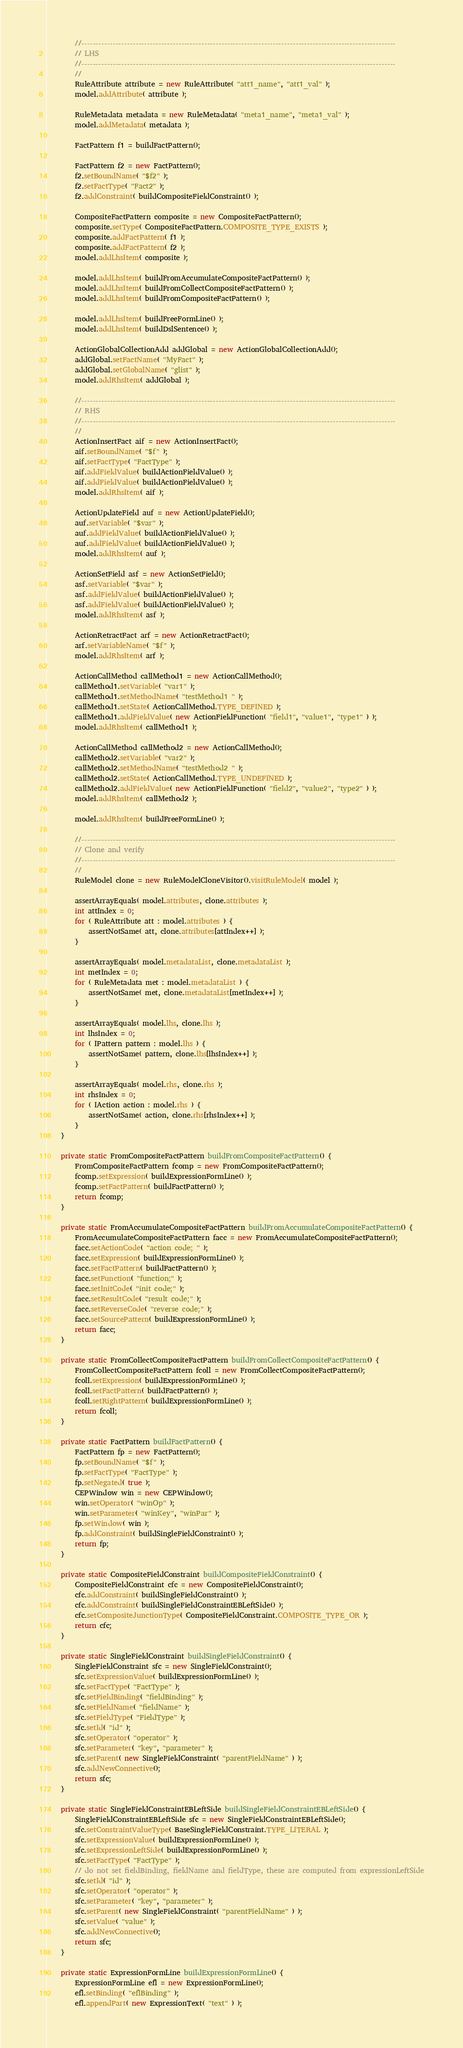<code> <loc_0><loc_0><loc_500><loc_500><_Java_>        //--------------------------------------------------------------------------------------------------------------
        // LHS
        //--------------------------------------------------------------------------------------------------------------
        //
        RuleAttribute attribute = new RuleAttribute( "att1_name", "att1_val" );
        model.addAttribute( attribute );

        RuleMetadata metadata = new RuleMetadata( "meta1_name", "meta1_val" );
        model.addMetadata( metadata );

        FactPattern f1 = buildFactPattern();

        FactPattern f2 = new FactPattern();
        f2.setBoundName( "$f2" );
        f2.setFactType( "Fact2" );
        f2.addConstraint( buildCompositeFieldConstraint() );

        CompositeFactPattern composite = new CompositeFactPattern();
        composite.setType( CompositeFactPattern.COMPOSITE_TYPE_EXISTS );
        composite.addFactPattern( f1 );
        composite.addFactPattern( f2 );
        model.addLhsItem( composite );

        model.addLhsItem( buildFromAccumulateCompositeFactPattern() );
        model.addLhsItem( buildFromCollectCompositeFactPattern() );
        model.addLhsItem( buildFromCompositeFactPattern() );

        model.addLhsItem( buildFreeFormLine() );
        model.addLhsItem( buildDslSentence() );

        ActionGlobalCollectionAdd addGlobal = new ActionGlobalCollectionAdd();
        addGlobal.setFactName( "MyFact" );
        addGlobal.setGlobalName( "glist" );
        model.addRhsItem( addGlobal );

        //--------------------------------------------------------------------------------------------------------------
        // RHS
        //--------------------------------------------------------------------------------------------------------------
        //
        ActionInsertFact aif = new ActionInsertFact();
        aif.setBoundName( "$f" );
        aif.setFactType( "FactType" );
        aif.addFieldValue( buildActionFieldValue() );
        aif.addFieldValue( buildActionFieldValue() );
        model.addRhsItem( aif );

        ActionUpdateField auf = new ActionUpdateField();
        auf.setVariable( "$var" );
        auf.addFieldValue( buildActionFieldValue() );
        auf.addFieldValue( buildActionFieldValue() );
        model.addRhsItem( auf );

        ActionSetField asf = new ActionSetField();
        asf.setVariable( "$var" );
        asf.addFieldValue( buildActionFieldValue() );
        asf.addFieldValue( buildActionFieldValue() );
        model.addRhsItem( asf );

        ActionRetractFact arf = new ActionRetractFact();
        arf.setVariableName( "$f" );
        model.addRhsItem( arf );

        ActionCallMethod callMethod1 = new ActionCallMethod();
        callMethod1.setVariable( "var1" );
        callMethod1.setMethodName( "testMethod1 " );
        callMethod1.setState( ActionCallMethod.TYPE_DEFINED );
        callMethod1.addFieldValue( new ActionFieldFunction( "field1", "value1", "type1" ) );
        model.addRhsItem( callMethod1 );

        ActionCallMethod callMethod2 = new ActionCallMethod();
        callMethod2.setVariable( "var2" );
        callMethod2.setMethodName( "testMethod2 " );
        callMethod2.setState( ActionCallMethod.TYPE_UNDEFINED );
        callMethod2.addFieldValue( new ActionFieldFunction( "field2", "value2", "type2" ) );
        model.addRhsItem( callMethod2 );

        model.addRhsItem( buildFreeFormLine() );

        //--------------------------------------------------------------------------------------------------------------
        // Clone and verify
        //--------------------------------------------------------------------------------------------------------------
        //
        RuleModel clone = new RuleModelCloneVisitor().visitRuleModel( model );

        assertArrayEquals( model.attributes, clone.attributes );
        int attIndex = 0;
        for ( RuleAttribute att : model.attributes ) {
            assertNotSame( att, clone.attributes[attIndex++] );
        }

        assertArrayEquals( model.metadataList, clone.metadataList );
        int metIndex = 0;
        for ( RuleMetadata met : model.metadataList ) {
            assertNotSame( met, clone.metadataList[metIndex++] );
        }

        assertArrayEquals( model.lhs, clone.lhs );
        int lhsIndex = 0;
        for ( IPattern pattern : model.lhs ) {
            assertNotSame( pattern, clone.lhs[lhsIndex++] );
        }

        assertArrayEquals( model.rhs, clone.rhs );
        int rhsIndex = 0;
        for ( IAction action : model.rhs ) {
            assertNotSame( action, clone.rhs[rhsIndex++] );
        }
    }

    private static FromCompositeFactPattern buildFromCompositeFactPattern() {
        FromCompositeFactPattern fcomp = new FromCompositeFactPattern();
        fcomp.setExpression( buildExpressionFormLine() );
        fcomp.setFactPattern( buildFactPattern() );
        return fcomp;
    }

    private static FromAccumulateCompositeFactPattern buildFromAccumulateCompositeFactPattern() {
        FromAccumulateCompositeFactPattern facc = new FromAccumulateCompositeFactPattern();
        facc.setActionCode( "action code; " );
        facc.setExpression( buildExpressionFormLine() );
        facc.setFactPattern( buildFactPattern() );
        facc.setFunction( "function;" );
        facc.setInitCode( "init code;" );
        facc.setResultCode( "result code;" );
        facc.setReverseCode( "reverse code;" );
        facc.setSourcePattern( buildExpressionFormLine() );
        return facc;
    }

    private static FromCollectCompositeFactPattern buildFromCollectCompositeFactPattern() {
        FromCollectCompositeFactPattern fcoll = new FromCollectCompositeFactPattern();
        fcoll.setExpression( buildExpressionFormLine() );
        fcoll.setFactPattern( buildFactPattern() );
        fcoll.setRightPattern( buildExpressionFormLine() );
        return fcoll;
    }

    private static FactPattern buildFactPattern() {
        FactPattern fp = new FactPattern();
        fp.setBoundName( "$f" );
        fp.setFactType( "FactType" );
        fp.setNegated( true );
        CEPWindow win = new CEPWindow();
        win.setOperator( "winOp" );
        win.setParameter( "winKey", "winPar" );
        fp.setWindow( win );
        fp.addConstraint( buildSingleFieldConstraint() );
        return fp;
    }

    private static CompositeFieldConstraint buildCompositeFieldConstraint() {
        CompositeFieldConstraint cfc = new CompositeFieldConstraint();
        cfc.addConstraint( buildSingleFieldConstraint() );
        cfc.addConstraint( buildSingleFieldConstraintEBLeftSide() );
        cfc.setCompositeJunctionType( CompositeFieldConstraint.COMPOSITE_TYPE_OR );
        return cfc;
    }

    private static SingleFieldConstraint buildSingleFieldConstraint() {
        SingleFieldConstraint sfc = new SingleFieldConstraint();
        sfc.setExpressionValue( buildExpressionFormLine() );
        sfc.setFactType( "FactType" );
        sfc.setFieldBinding( "fieldBinding" );
        sfc.setFieldName( "fieldName" );
        sfc.setFieldType( "FieldType" );
        sfc.setId( "id" );
        sfc.setOperator( "operator" );
        sfc.setParameter( "key", "parameter" );
        sfc.setParent( new SingleFieldConstraint( "parentFieldName" ) );
        sfc.addNewConnective();
        return sfc;
    }

    private static SingleFieldConstraintEBLeftSide buildSingleFieldConstraintEBLeftSide() {
        SingleFieldConstraintEBLeftSide sfc = new SingleFieldConstraintEBLeftSide();
        sfc.setConstraintValueType( BaseSingleFieldConstraint.TYPE_LITERAL );
        sfc.setExpressionValue( buildExpressionFormLine() );
        sfc.setExpressionLeftSide( buildExpressionFormLine() );
        sfc.setFactType( "FactType" );
        // do not set fieldBinding, fieldName and fieldType, these are computed from expressionLeftSide
        sfc.setId( "id" );
        sfc.setOperator( "operator" );
        sfc.setParameter( "key", "parameter" );
        sfc.setParent( new SingleFieldConstraint( "parentFieldName" ) );
        sfc.setValue( "value" );
        sfc.addNewConnective();
        return sfc;
    }

    private static ExpressionFormLine buildExpressionFormLine() {
        ExpressionFormLine efl = new ExpressionFormLine();
        efl.setBinding( "eflBinding" );
        efl.appendPart( new ExpressionText( "text" ) );</code> 